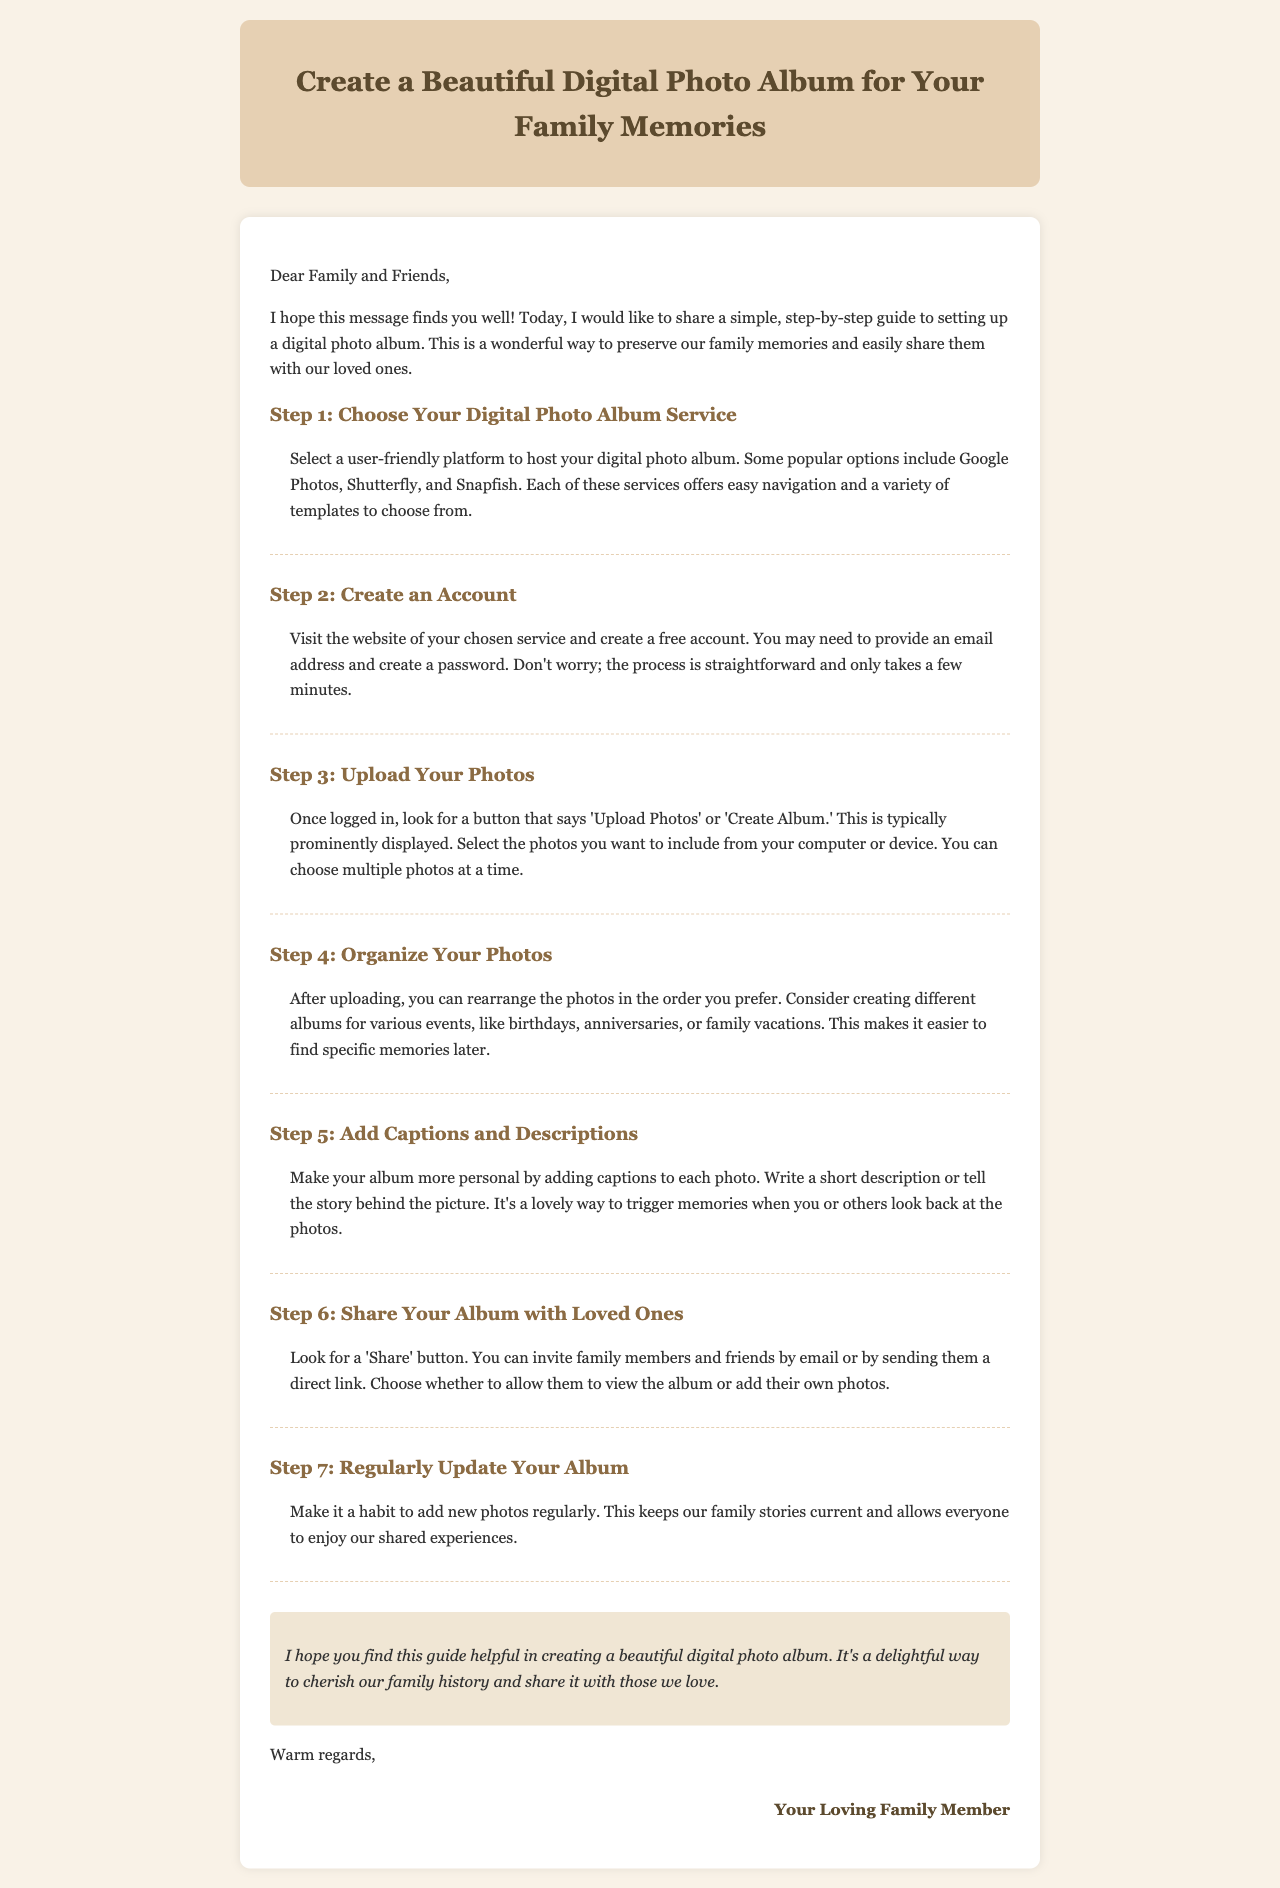what is the title of the guide? The title is prominently displayed at the top of the document, stating the purpose of the content.
Answer: Create a Beautiful Digital Photo Album for Your Family Memories how many steps are there in the guide? The document lists out seven clear and distinct steps to follow for creating a digital photo album.
Answer: 7 which step involves uploading photos? The step specifically detailing the action of uploading photos is highlighted in the document.
Answer: Step 3 what platform options are suggested in Step 1? The first step includes a selection of user-friendly photo album hosting services.
Answer: Google Photos, Shutterfly, Snapfish what should you do after uploading photos? The document describes specific actions you can take with your uploaded photos.
Answer: Organize Your Photos how can you share your album? The document outlines a method to share the photo album with others.
Answer: By email or sending a direct link who is the author of the email? The sign-off at the end of the document indicates who has sent the email.
Answer: Your Loving Family Member 